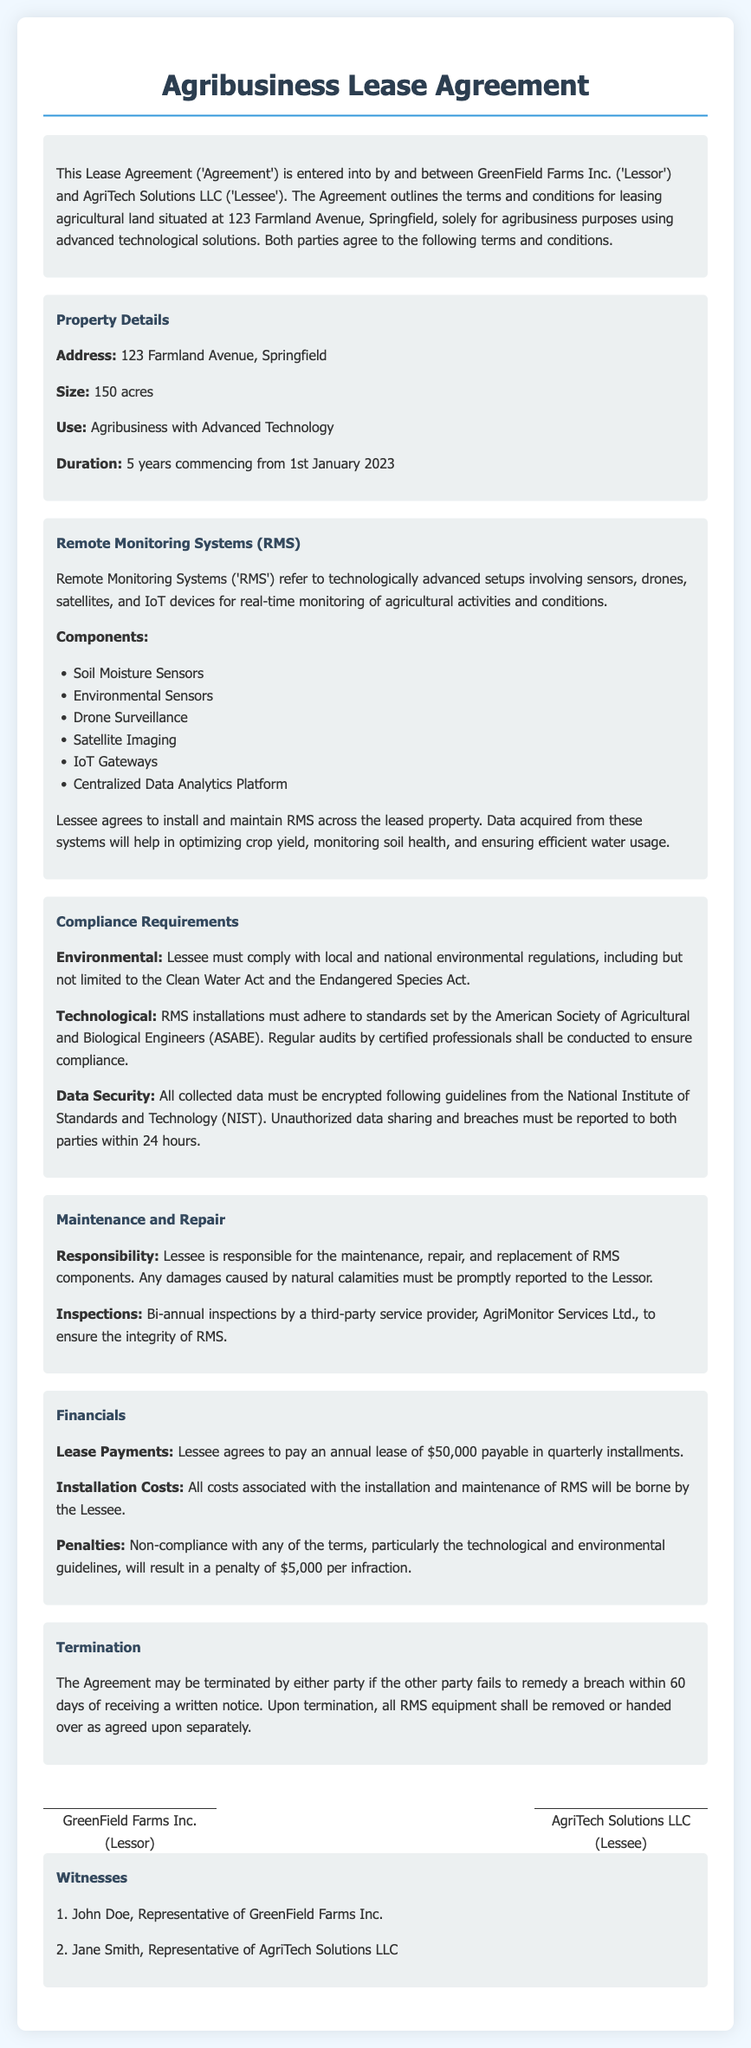what is the location of the leased property? The document specifies that the leased property is situated at 123 Farmland Avenue, Springfield.
Answer: 123 Farmland Avenue, Springfield how many acres is the leased property? The size of the leased property is stated as 150 acres in the document.
Answer: 150 acres what is the duration of the lease? The lease duration is mentioned as 5 years, commencing from 1st January 2023.
Answer: 5 years which organization is responsible for bi-annual inspections? The document states that AgriMonitor Services Ltd. is the third-party service provider responsible for inspections.
Answer: AgriMonitor Services Ltd what financial penalty is imposed for non-compliance? The document indicates that non-compliance incurs a penalty of $5,000 per infraction.
Answer: $5,000 which technological standards must RMS installations comply with? The RMS installations must adhere to the standards set by the American Society of Agricultural and Biological Engineers.
Answer: American Society of Agricultural and Biological Engineers who are the parties involved in the lease agreement? The lease agreement is entered into by GreenField Farms Inc. as Lessor and AgriTech Solutions LLC as Lessee.
Answer: GreenField Farms Inc. and AgriTech Solutions LLC what must be done with collected data according to the compliance requirements? The document specifies that all collected data must be encrypted following NIST guidelines.
Answer: Encrypted following NIST guidelines what happens to RMS equipment upon termination of the agreement? The agreement states that upon termination, all RMS equipment shall be removed or handed over as agreed upon separately.
Answer: Removed or handed over as agreed upon 